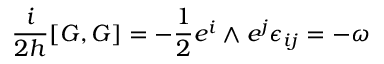<formula> <loc_0><loc_0><loc_500><loc_500>\frac { i } { 2 h } [ G , G ] = - \frac { 1 } { 2 } e ^ { i } \wedge e ^ { j } \epsilon _ { i j } = - \omega</formula> 